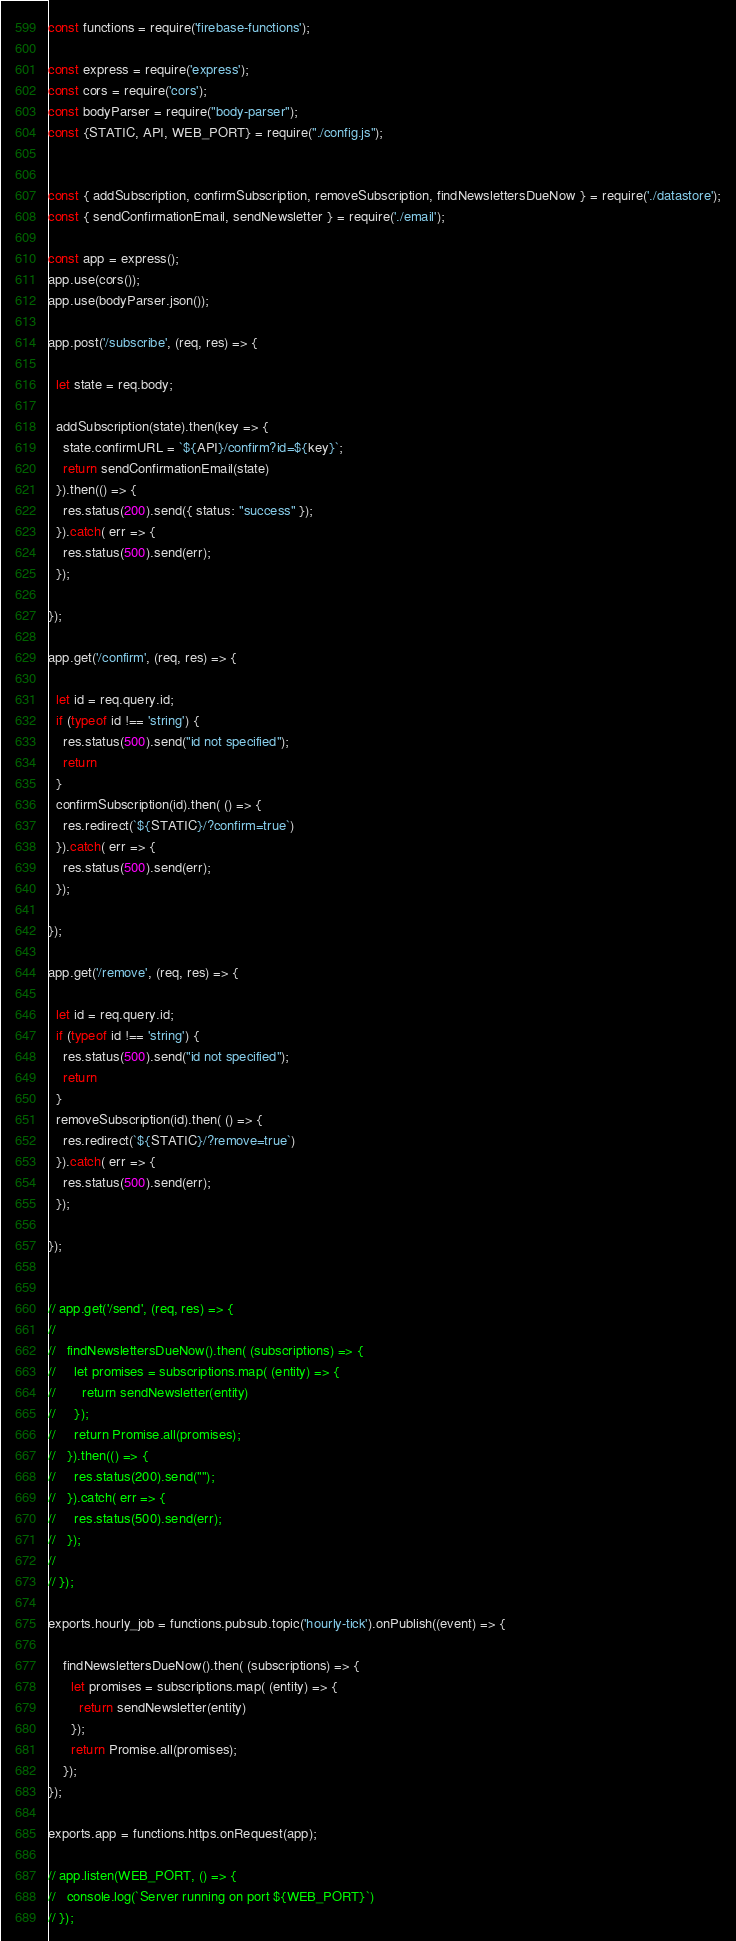Convert code to text. <code><loc_0><loc_0><loc_500><loc_500><_JavaScript_>const functions = require('firebase-functions');

const express = require('express');
const cors = require('cors');
const bodyParser = require("body-parser");
const {STATIC, API, WEB_PORT} = require("./config.js");


const { addSubscription, confirmSubscription, removeSubscription, findNewslettersDueNow } = require('./datastore');
const { sendConfirmationEmail, sendNewsletter } = require('./email');

const app = express();
app.use(cors());
app.use(bodyParser.json());

app.post('/subscribe', (req, res) => {

  let state = req.body;

  addSubscription(state).then(key => {
    state.confirmURL = `${API}/confirm?id=${key}`;
    return sendConfirmationEmail(state)
  }).then(() => {
    res.status(200).send({ status: "success" });
  }).catch( err => {
    res.status(500).send(err);
  });

});

app.get('/confirm', (req, res) => {

  let id = req.query.id;
  if (typeof id !== 'string') {
    res.status(500).send("id not specified");
    return
  }
  confirmSubscription(id).then( () => {
    res.redirect(`${STATIC}/?confirm=true`)
  }).catch( err => {
    res.status(500).send(err);
  });

});

app.get('/remove', (req, res) => {

  let id = req.query.id;
  if (typeof id !== 'string') {
    res.status(500).send("id not specified");
    return
  }
  removeSubscription(id).then( () => {
    res.redirect(`${STATIC}/?remove=true`)
  }).catch( err => {
    res.status(500).send(err);
  });

});


// app.get('/send', (req, res) => {
//
//   findNewslettersDueNow().then( (subscriptions) => {
//     let promises = subscriptions.map( (entity) => {
//       return sendNewsletter(entity)
//     });
//     return Promise.all(promises);
//   }).then(() => {
//     res.status(200).send("");
//   }).catch( err => {
//     res.status(500).send(err);
//   });
//
// });

exports.hourly_job = functions.pubsub.topic('hourly-tick').onPublish((event) => {

    findNewslettersDueNow().then( (subscriptions) => {
      let promises = subscriptions.map( (entity) => {
        return sendNewsletter(entity)
      });
      return Promise.all(promises);
    });
});

exports.app = functions.https.onRequest(app);

// app.listen(WEB_PORT, () => {
//   console.log(`Server running on port ${WEB_PORT}`)
// });


</code> 